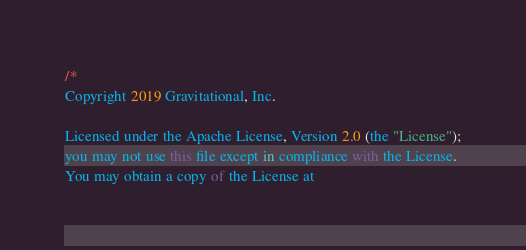<code> <loc_0><loc_0><loc_500><loc_500><_JavaScript_>/*
Copyright 2019 Gravitational, Inc.

Licensed under the Apache License, Version 2.0 (the "License");
you may not use this file except in compliance with the License.
You may obtain a copy of the License at
</code> 